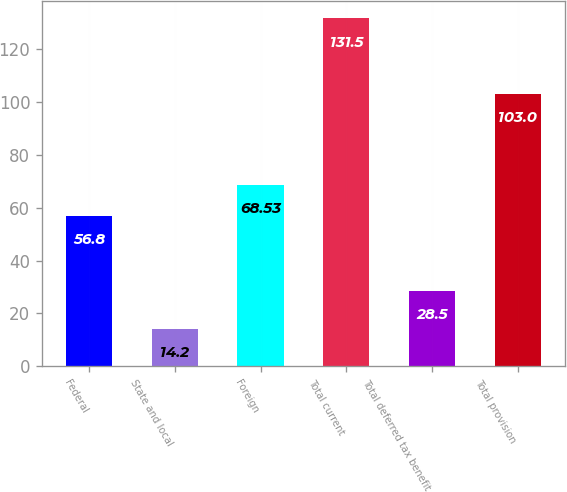<chart> <loc_0><loc_0><loc_500><loc_500><bar_chart><fcel>Federal<fcel>State and local<fcel>Foreign<fcel>Total current<fcel>Total deferred tax benefit<fcel>Total provision<nl><fcel>56.8<fcel>14.2<fcel>68.53<fcel>131.5<fcel>28.5<fcel>103<nl></chart> 